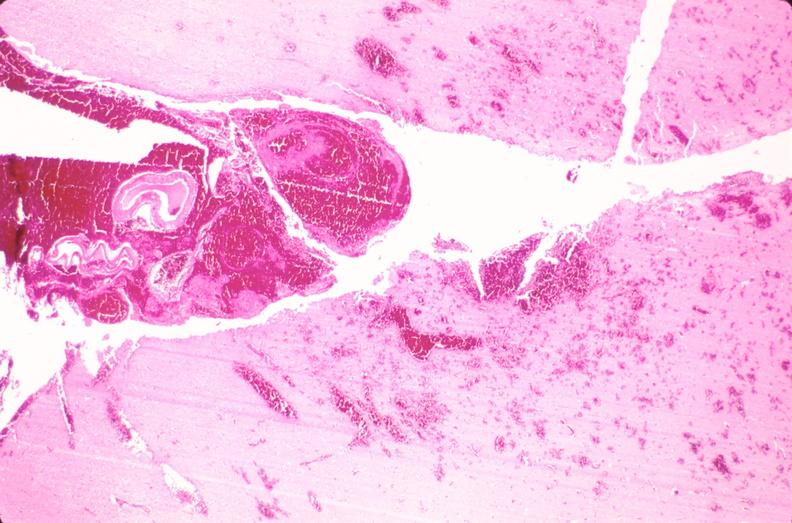s nervous present?
Answer the question using a single word or phrase. Yes 